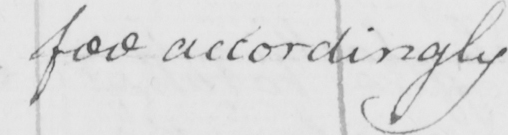Please transcribe the handwritten text in this image. fee accordingly 